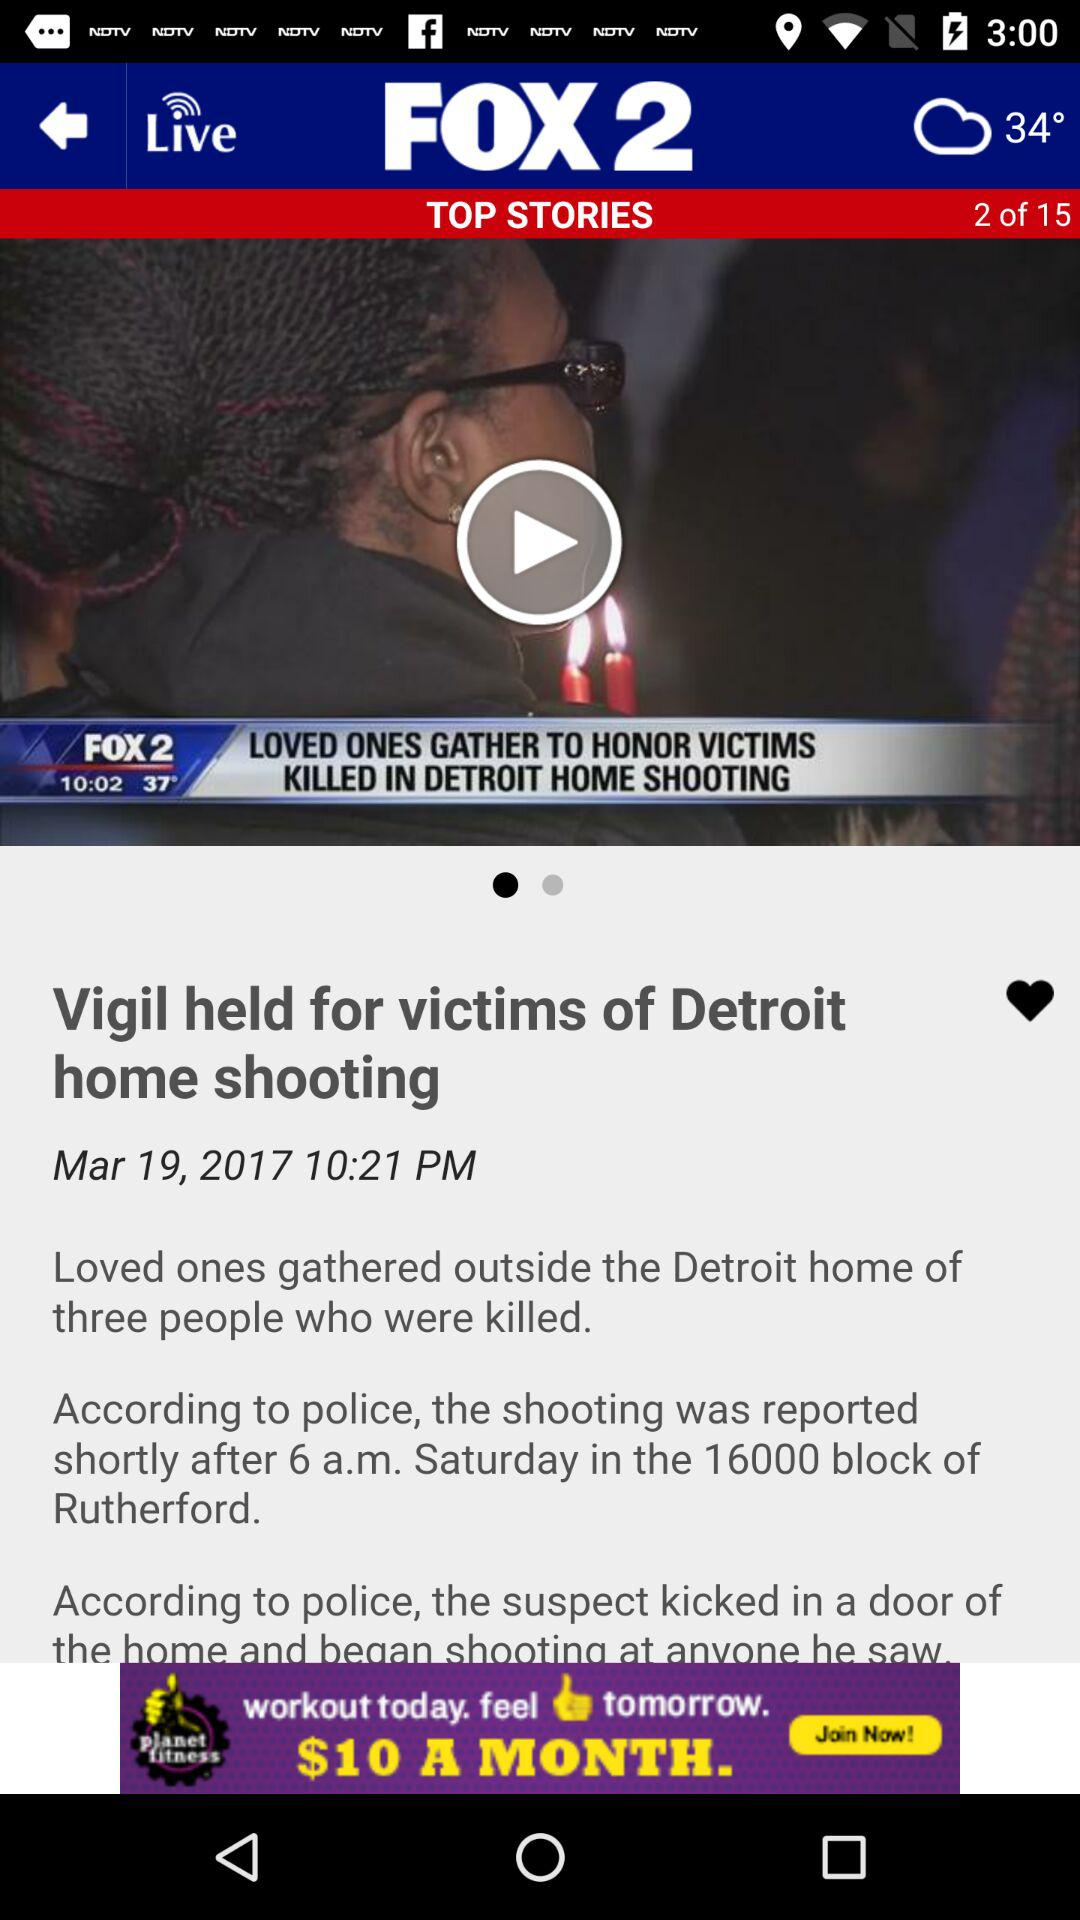What temperature is showing on the screen? The temperature is 34°. 